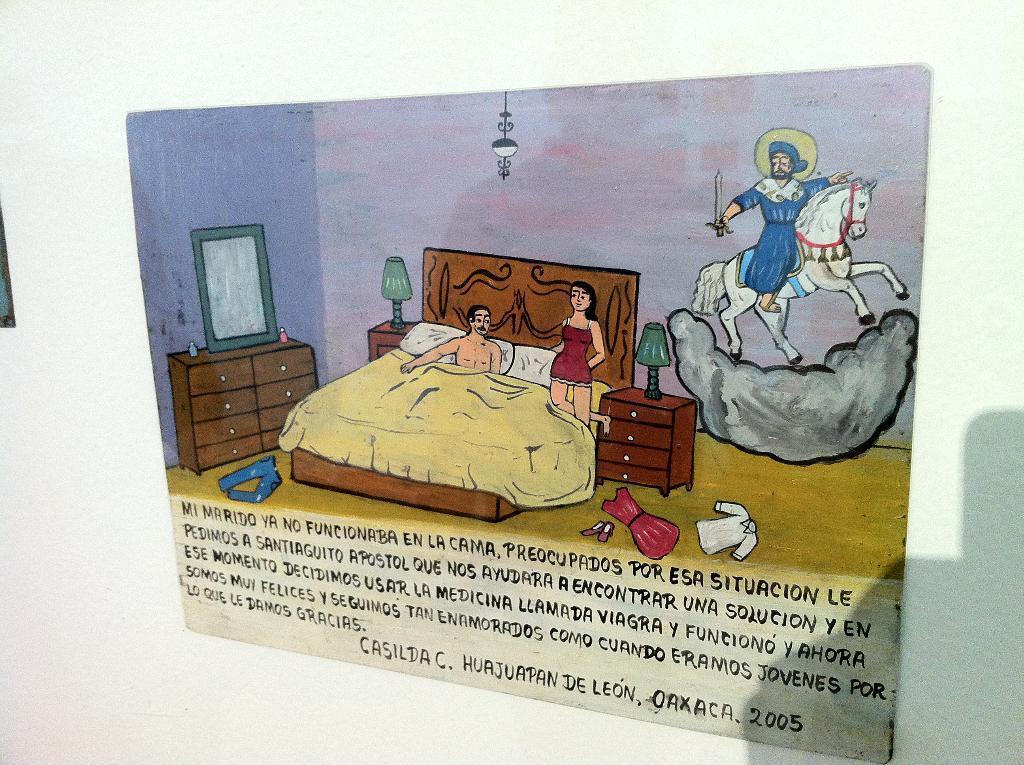Describe this image in one or two sentences. In this image I can see depiction picture where I can see few people, few lamps, a light, a mirror, few hours, few clothes, a shoe and here I can see a person is sitting on a horse. I can also see something is written over here. 